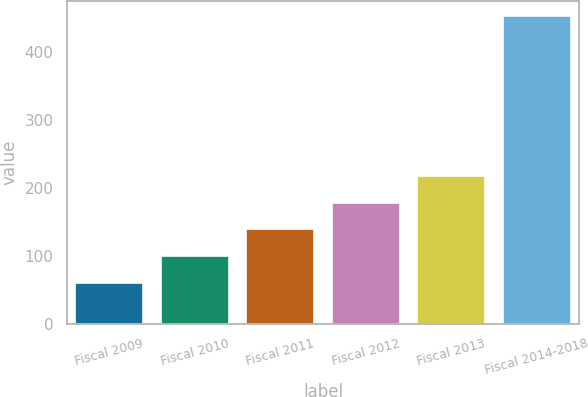<chart> <loc_0><loc_0><loc_500><loc_500><bar_chart><fcel>Fiscal 2009<fcel>Fiscal 2010<fcel>Fiscal 2011<fcel>Fiscal 2012<fcel>Fiscal 2013<fcel>Fiscal 2014-2018<nl><fcel>61<fcel>100.2<fcel>139.4<fcel>178.6<fcel>217.8<fcel>453<nl></chart> 